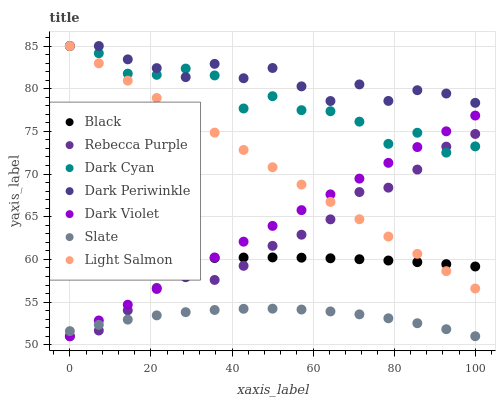Does Slate have the minimum area under the curve?
Answer yes or no. Yes. Does Dark Periwinkle have the maximum area under the curve?
Answer yes or no. Yes. Does Dark Violet have the minimum area under the curve?
Answer yes or no. No. Does Dark Violet have the maximum area under the curve?
Answer yes or no. No. Is Dark Violet the smoothest?
Answer yes or no. Yes. Is Dark Cyan the roughest?
Answer yes or no. Yes. Is Slate the smoothest?
Answer yes or no. No. Is Slate the roughest?
Answer yes or no. No. Does Dark Violet have the lowest value?
Answer yes or no. Yes. Does Slate have the lowest value?
Answer yes or no. No. Does Dark Periwinkle have the highest value?
Answer yes or no. Yes. Does Dark Violet have the highest value?
Answer yes or no. No. Is Slate less than Black?
Answer yes or no. Yes. Is Dark Cyan greater than Slate?
Answer yes or no. Yes. Does Dark Periwinkle intersect Light Salmon?
Answer yes or no. Yes. Is Dark Periwinkle less than Light Salmon?
Answer yes or no. No. Is Dark Periwinkle greater than Light Salmon?
Answer yes or no. No. Does Slate intersect Black?
Answer yes or no. No. 